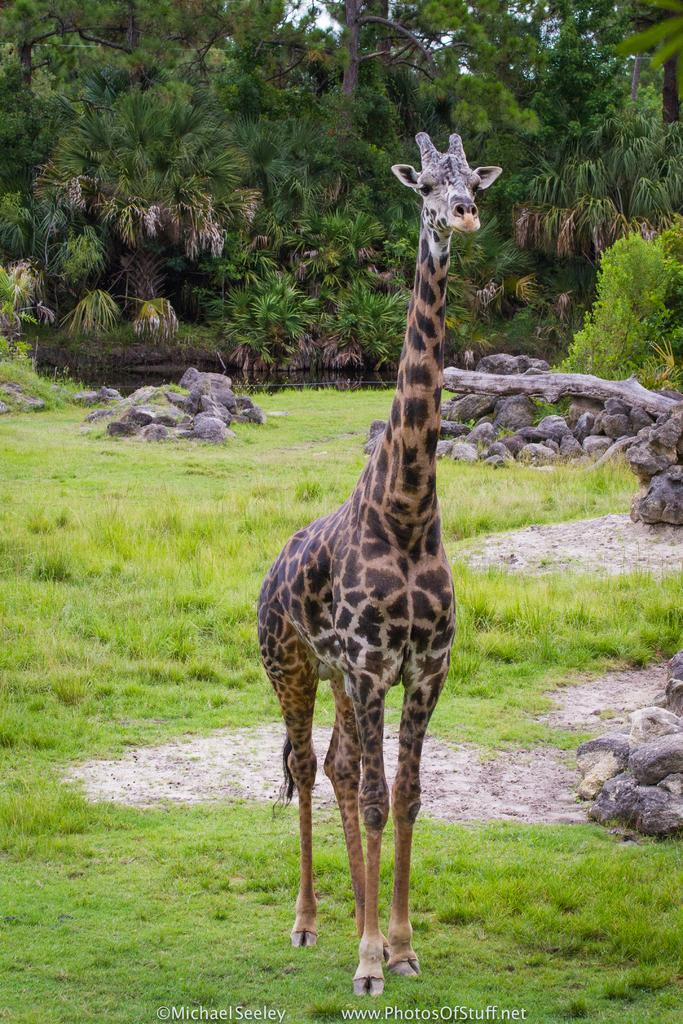What type of animal is in the image? There is a giraffe in the image. What is at the bottom of the image? There is green grass at the bottom of the image. What else can be seen on the ground in the image? There are rocks on the ground in the image. What is visible in the background of the image? There are trees in the background of the image. What type of tax is being discussed in the image? There is no mention of tax in the image; it features a giraffe, green grass, rocks, and trees. What color is the yarn being used by the giraffe in the image? There is no yarn present in the image, as it features a giraffe, green grass, rocks, and trees. 